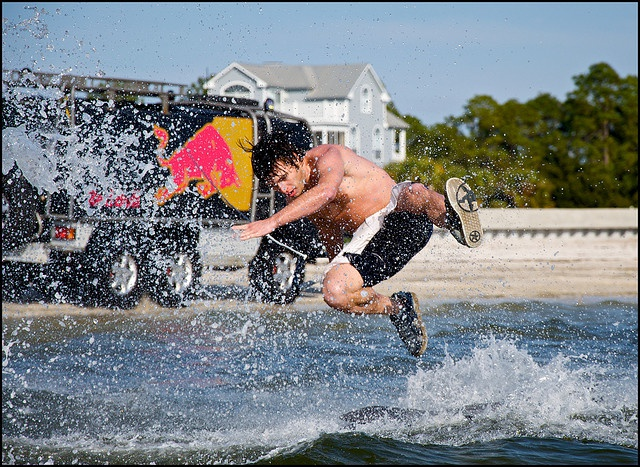Describe the objects in this image and their specific colors. I can see truck in black, darkgray, gray, and lightgray tones, people in black, lightpink, lightgray, and gray tones, and surfboard in black, darkgray, gray, and lightgray tones in this image. 